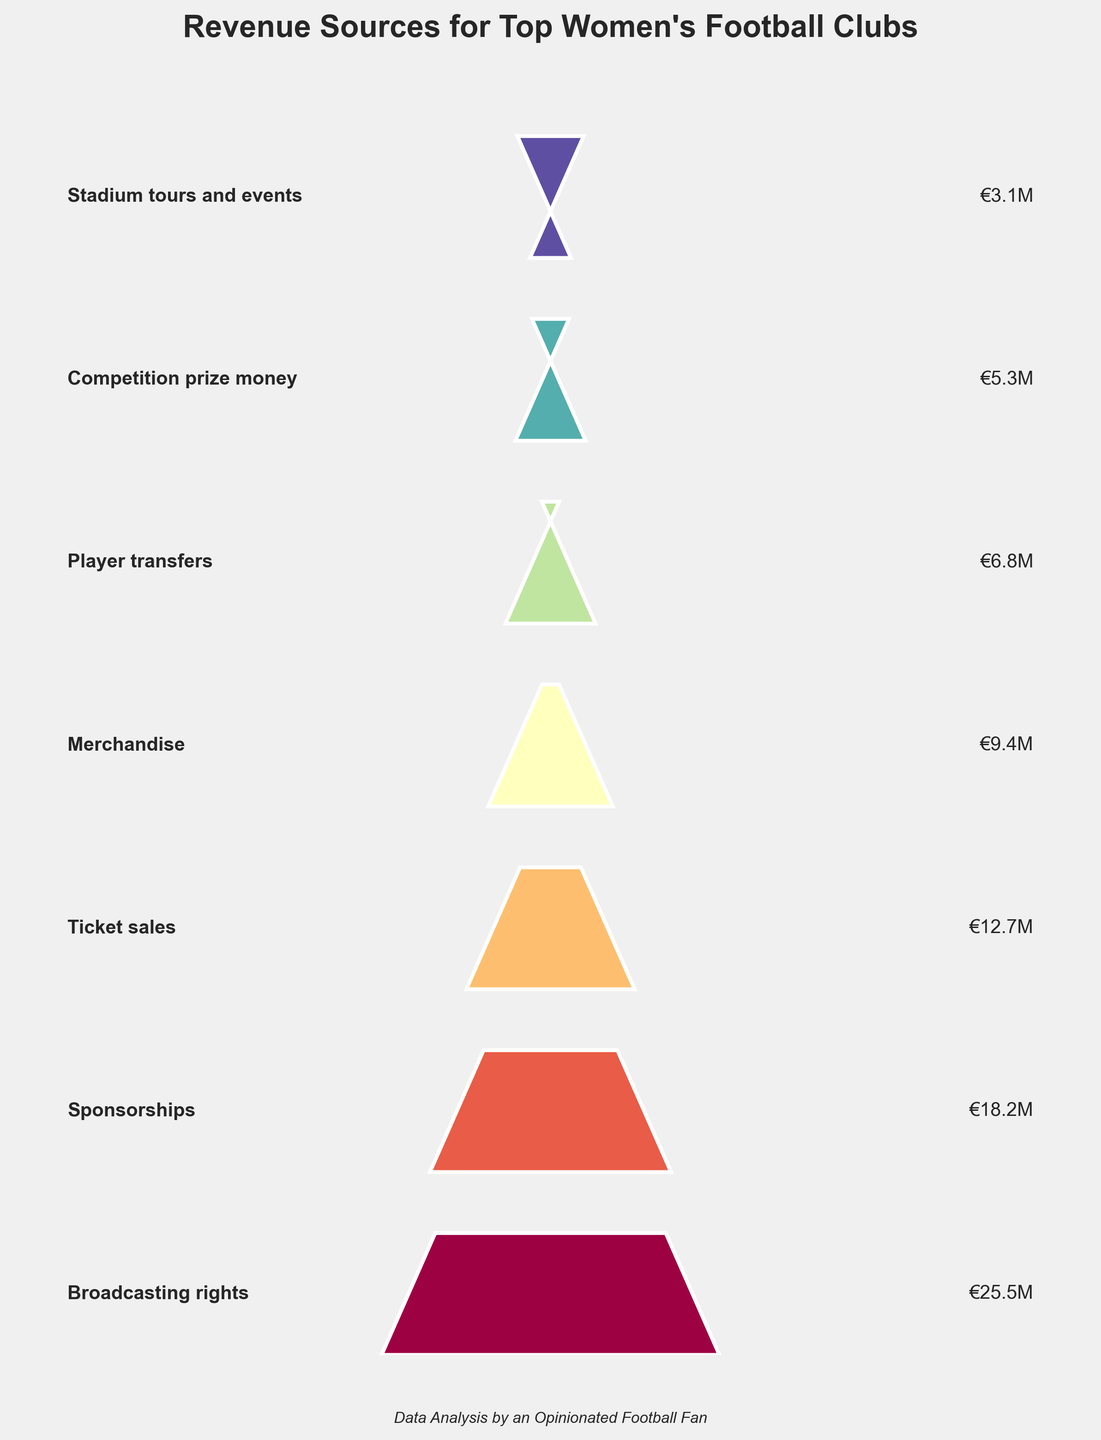How many revenue sources are represented in the funnel chart? Count the number of categories listed in the funnel chart.
Answer: 7 Which revenue source contributes the highest amount? Identify the category at the top (widest) part of the funnel chart.
Answer: Broadcasting rights What's the total revenue generated by player transfers and merchandise combined? Add the revenue from player transfers (€6.8M) and merchandise (€9.4M). €6.8M + €9.4M = €16.2M
Answer: €16.2M Which revenue source is greater, ticket sales or competition prize money, and by how much? Compare the revenue values of ticket sales (€12.7M) and competition prize money (€5.3M), then calculate the difference. €12.7M - €5.3M = €7.4M
Answer: Ticket sales by €7.4M How much more revenue is generated from broadcasting rights compared to stadium tours and events? Subtract the revenue of stadium tours and events (€3.1M) from broadcasting rights (€25.5M). €25.5M - €3.1M = €22.4M
Answer: €22.4M Is the revenue from sponsorships higher than ticket sales, and if so, by how much? Compare the revenue values of sponsorships (€18.2M) and ticket sales (€12.7M), then calculate the difference. €18.2M - €12.7M = €5.5M
Answer: Yes, by €5.5M What are the top three revenue sources in the funnel chart? Identify the three categories with the highest revenue amounts which are the widest segments at the top of the chart.
Answer: Broadcasting rights, Sponsorships, Ticket sales What is the average revenue generated from competition prize money and stadium tours and events? Calculate the average by adding the revenues from competition prize money (€5.3M) and stadium tours and events (€3.1M), then divide by 2. (€5.3M + €3.1M) / 2 = €4.2M
Answer: €4.2M Which revenue sources contribute less than €10M each? Identify categories with revenue less than €10M based on the funnel chart values.
Answer: Merchandise, Player transfers, Competition prize money, Stadium tours and events What percentage of the total revenue does the sponsorship category represent? Calculate the total revenue, then find the percentage of the sponsorship revenue. Total revenue is the sum of all categories: €25.5M + €18.2M + €12.7M + €9.4M + €6.8M + €5.3M + €3.1M = €81M. Percentage is (€18.2M / €81M) * 100 = 22.47%
Answer: 22.47% 